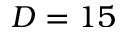<formula> <loc_0><loc_0><loc_500><loc_500>D = 1 5</formula> 